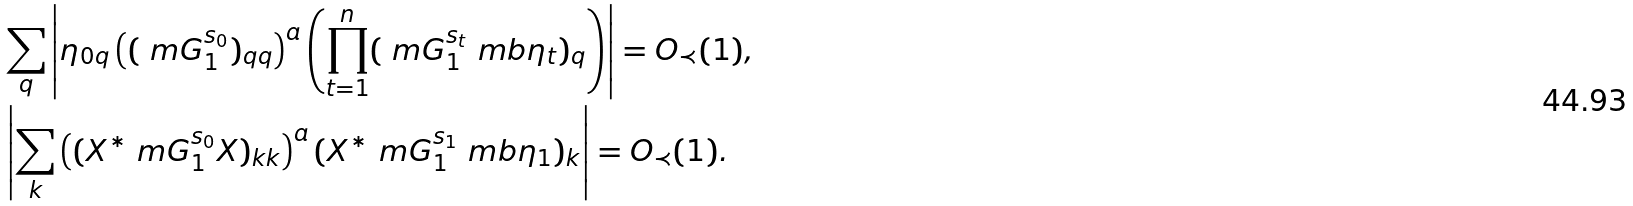<formula> <loc_0><loc_0><loc_500><loc_500>& \sum _ { q } \left | \eta _ { 0 q } \left ( ( \ m G _ { 1 } ^ { s _ { 0 } } ) _ { q q } \right ) ^ { a } \left ( \prod _ { t = 1 } ^ { n } ( \ m G _ { 1 } ^ { s _ { t } } \ m b { \eta } _ { t } ) _ { q } \right ) \right | = O _ { \prec } ( 1 ) , \\ & \left | \sum _ { k } \left ( ( X ^ { * } \ m G _ { 1 } ^ { s _ { 0 } } X ) _ { k k } \right ) ^ { a } ( X ^ { * } \ m G _ { 1 } ^ { s _ { 1 } } \ m b { \eta } _ { 1 } ) _ { k } \right | = O _ { \prec } ( 1 ) .</formula> 